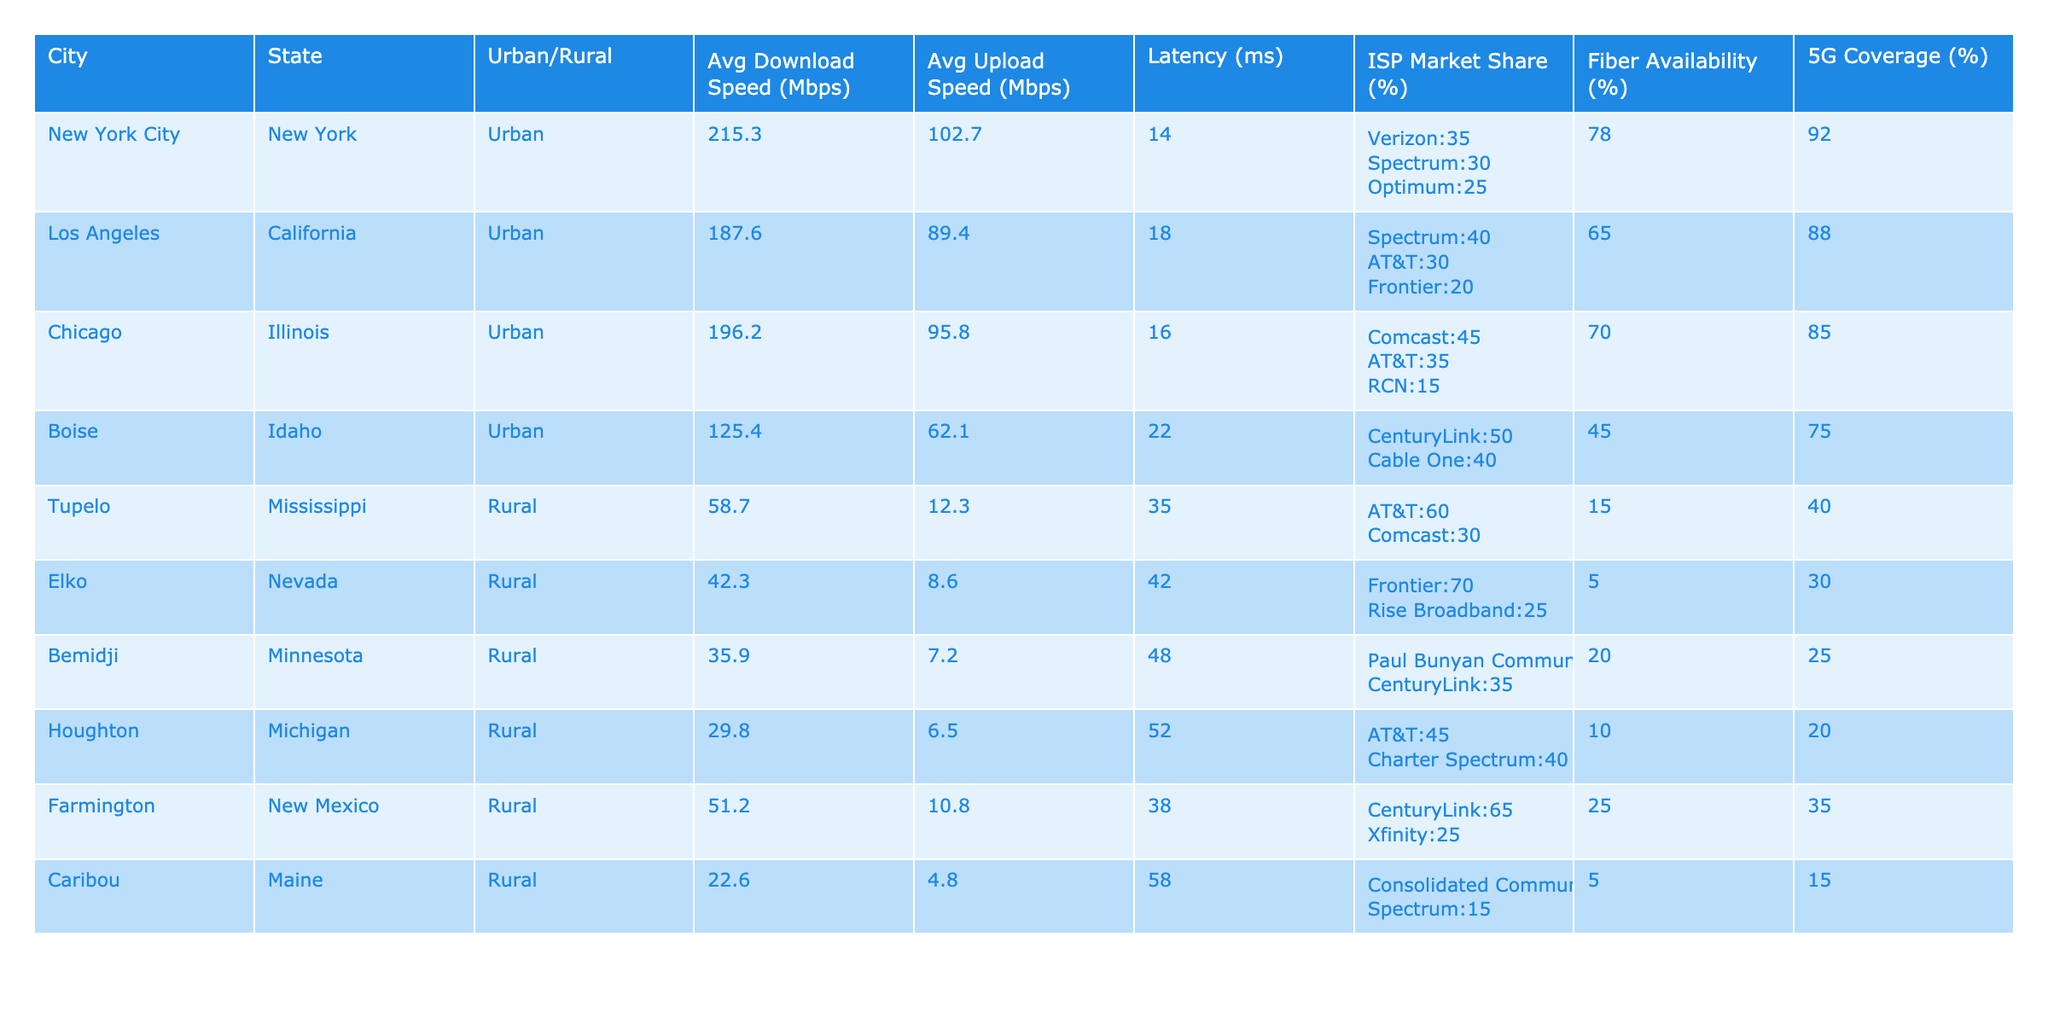What is the average download speed for urban areas? To find the average download speed for urban areas, we consider the download speeds listed for all urban cities: New York City (215.3), Los Angeles (187.6), Chicago (196.2), and Boise (125.4). The sum is (215.3 + 187.6 + 196.2 + 125.4) = 724.5. There are 4 urban areas, so we divide by 4: 724.5 / 4 = 181.125.
Answer: 181.125 Which city has the highest average upload speed? By examining the upload speeds in the table, we compare each city's value: New York City (102.7), Los Angeles (89.4), Chicago (95.8), Boise (62.1), Tupelo (12.3), Elko (8.6), Bemidji (7.2), Houghton (6.5), Farmington (10.8), and Caribou (4.8). New York City has the highest value at 102.7 Mbps.
Answer: New York City Is there a city with fiber availability lower than 10%? We look for cities in the table that have fiber availability values: New York City (78), Los Angeles (65), Chicago (70), Boise (45), Tupelo (15), Elko (5), Bemidji (20), Houghton (10), Farmington (25), and Caribou (5). Elko and Caribou both have fiber availability below 10%.
Answer: Yes What is the difference in average download speeds between urban and rural areas? We first find the average download speed for rural areas using the provided values: Tupelo (58.7), Elko (42.3), Bemidji (35.9), Houghton (29.8), Farmington (51.2), and Caribou (22.6). The sum is (58.7 + 42.3 + 35.9 + 29.8 + 51.2 + 22.6) = 240.5, and there are 6 rural areas: 240.5 / 6 = 40.08333. The average download speed for urban areas was previously calculated as 181.125. The difference is 181.125 - 40.08333 = 141.04167.
Answer: 141.04167 What percentage of the total market share does the highest ISP represent in urban areas? We identify the ISPs and their market shares in urban areas. New York City has Verizon (35%), Los Angeles has Spectrum (40%), Chicago has Comcast (45%), and Boise has CenturyLink (50%). The highest market share is 50% from CenturyLink. Therefore, the required percentage of total market share in urban areas is simply 50% directly.
Answer: 50% 